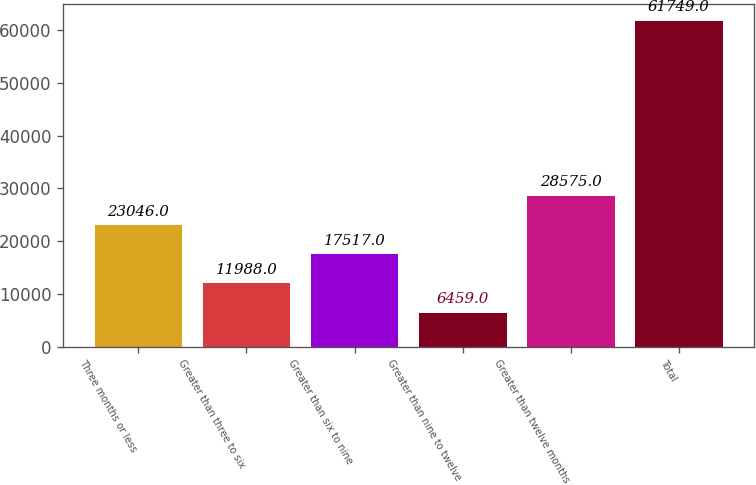Convert chart to OTSL. <chart><loc_0><loc_0><loc_500><loc_500><bar_chart><fcel>Three months or less<fcel>Greater than three to six<fcel>Greater than six to nine<fcel>Greater than nine to twelve<fcel>Greater than twelve months<fcel>Total<nl><fcel>23046<fcel>11988<fcel>17517<fcel>6459<fcel>28575<fcel>61749<nl></chart> 